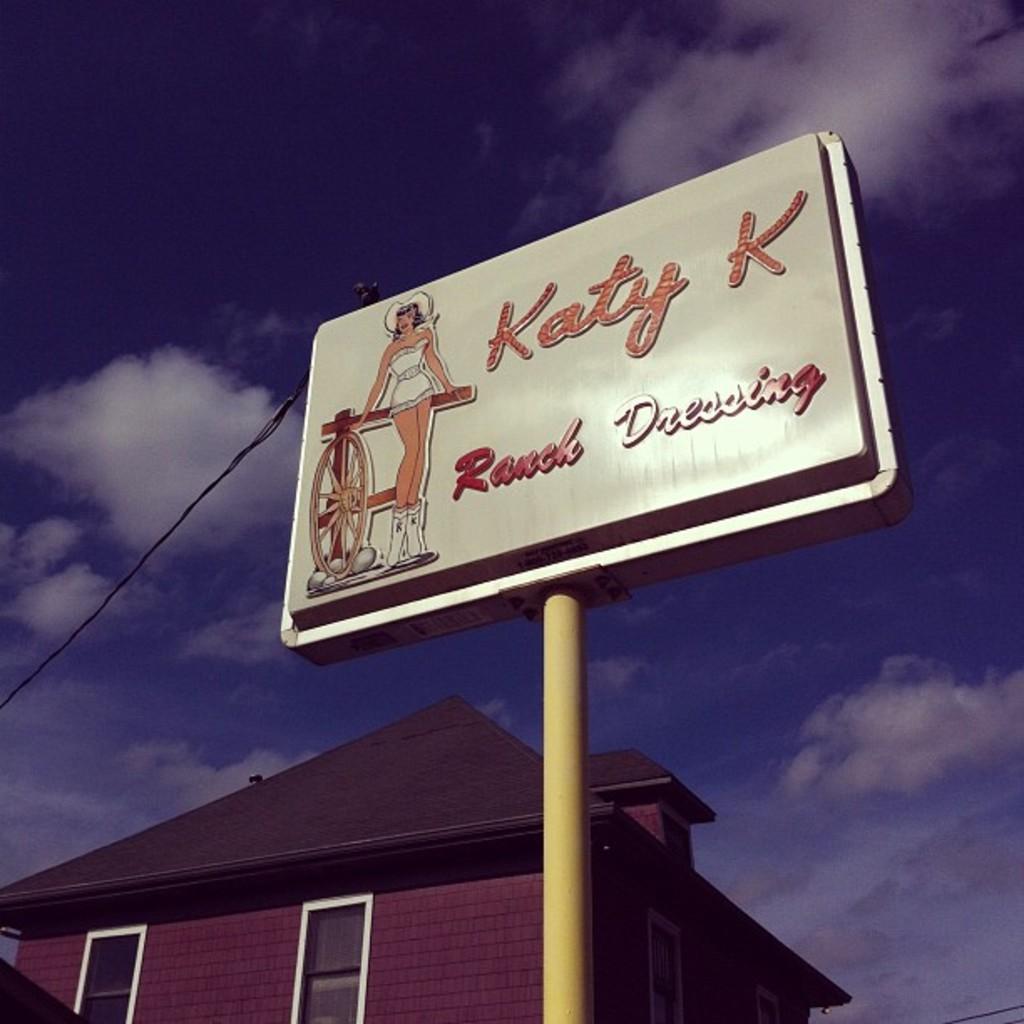What is the name of the woman on the sign?
Ensure brevity in your answer.  Katy k. What does katy k produce?
Your response must be concise. Ranch dressing. 